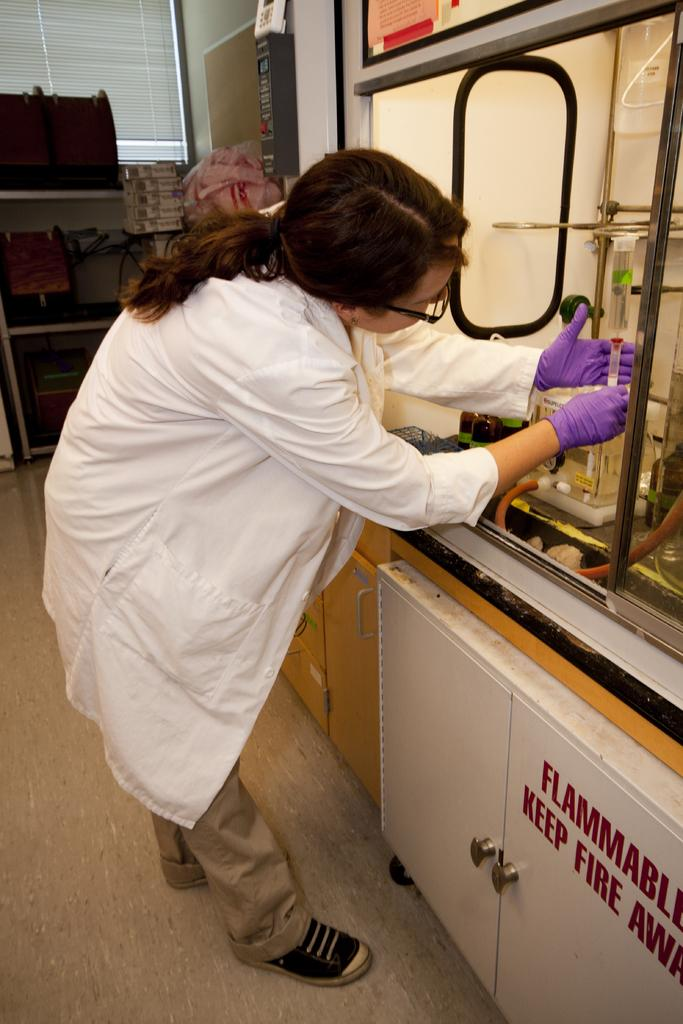<image>
Render a clear and concise summary of the photo. a scientist stands in front of a sign which reads Flammable in red. 